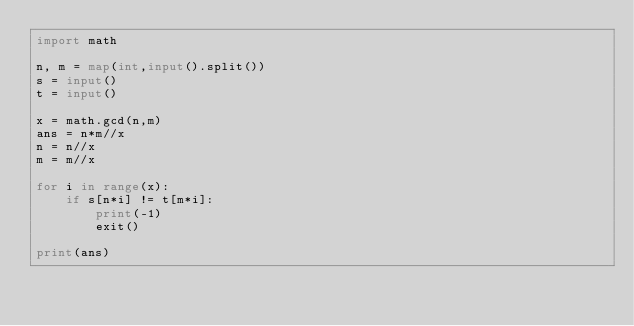Convert code to text. <code><loc_0><loc_0><loc_500><loc_500><_Python_>import math

n, m = map(int,input().split())
s = input()
t = input()

x = math.gcd(n,m)
ans = n*m//x
n = n//x
m = m//x

for i in range(x):
    if s[n*i] != t[m*i]:
        print(-1)
        exit()

print(ans)</code> 